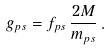Convert formula to latex. <formula><loc_0><loc_0><loc_500><loc_500>g _ { p s } = f _ { p s } \, \frac { 2 M } { m _ { p s } } \, .</formula> 